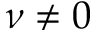Convert formula to latex. <formula><loc_0><loc_0><loc_500><loc_500>\nu \neq 0</formula> 